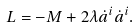Convert formula to latex. <formula><loc_0><loc_0><loc_500><loc_500>L = - M + 2 \lambda \dot { a } ^ { i } \dot { a } ^ { i } .</formula> 